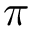<formula> <loc_0><loc_0><loc_500><loc_500>\pi</formula> 